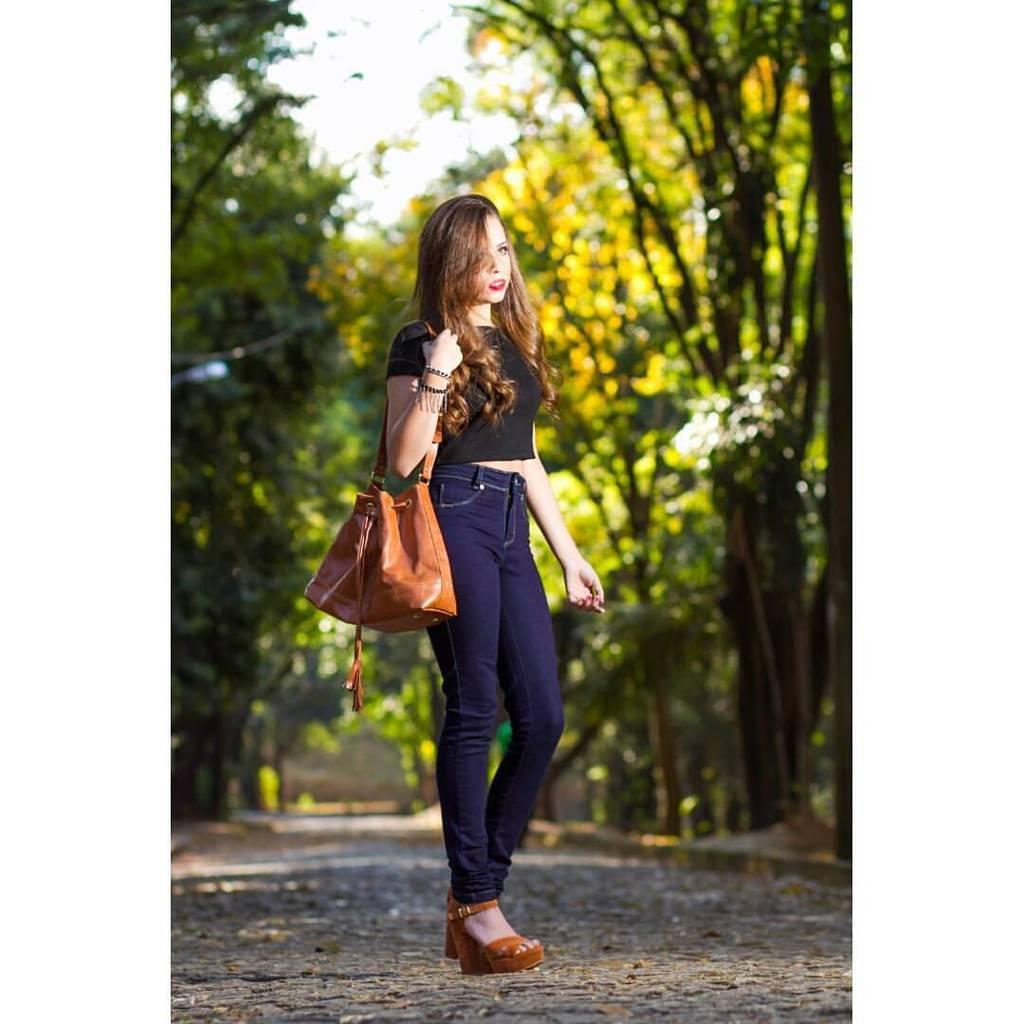Could you give a brief overview of what you see in this image? In this image in the middle there is a woman she wears t shirt, trouser and handbag her hair is short. In the background there are trees and sky and road. 